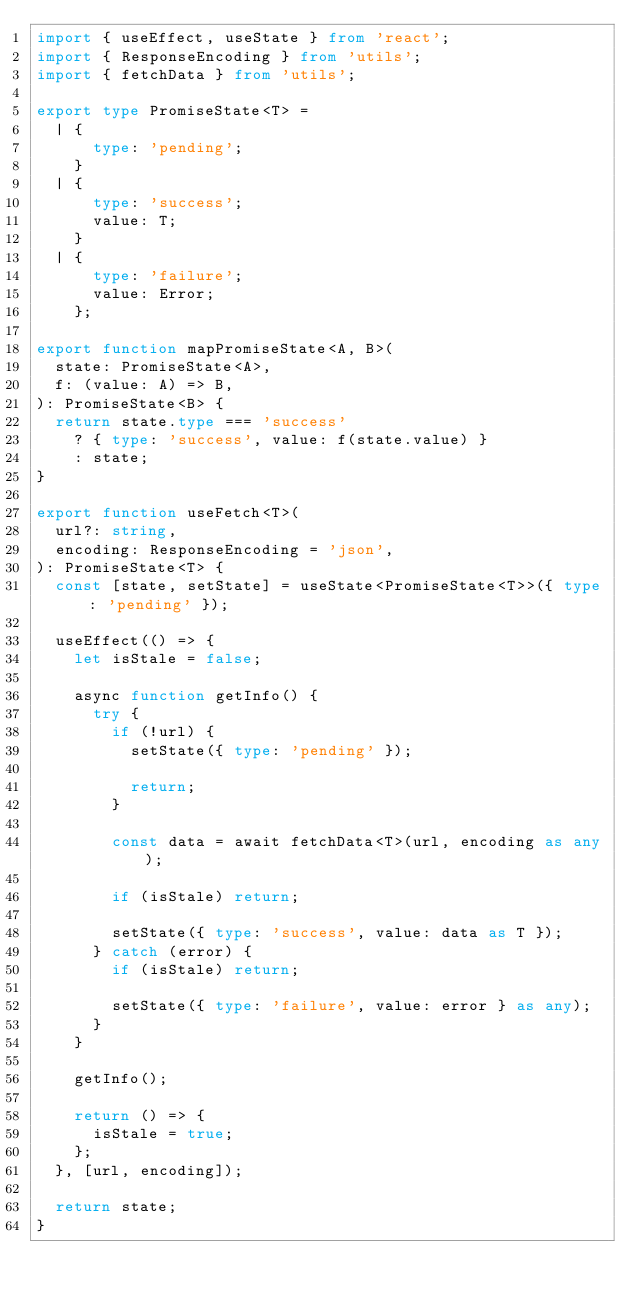Convert code to text. <code><loc_0><loc_0><loc_500><loc_500><_TypeScript_>import { useEffect, useState } from 'react';
import { ResponseEncoding } from 'utils';
import { fetchData } from 'utils';

export type PromiseState<T> =
  | {
      type: 'pending';
    }
  | {
      type: 'success';
      value: T;
    }
  | {
      type: 'failure';
      value: Error;
    };

export function mapPromiseState<A, B>(
  state: PromiseState<A>,
  f: (value: A) => B,
): PromiseState<B> {
  return state.type === 'success'
    ? { type: 'success', value: f(state.value) }
    : state;
}

export function useFetch<T>(
  url?: string,
  encoding: ResponseEncoding = 'json',
): PromiseState<T> {
  const [state, setState] = useState<PromiseState<T>>({ type: 'pending' });

  useEffect(() => {
    let isStale = false;

    async function getInfo() {
      try {
        if (!url) {
          setState({ type: 'pending' });

          return;
        }

        const data = await fetchData<T>(url, encoding as any);

        if (isStale) return;

        setState({ type: 'success', value: data as T });
      } catch (error) {
        if (isStale) return;

        setState({ type: 'failure', value: error } as any);
      }
    }

    getInfo();

    return () => {
      isStale = true;
    };
  }, [url, encoding]);

  return state;
}
</code> 